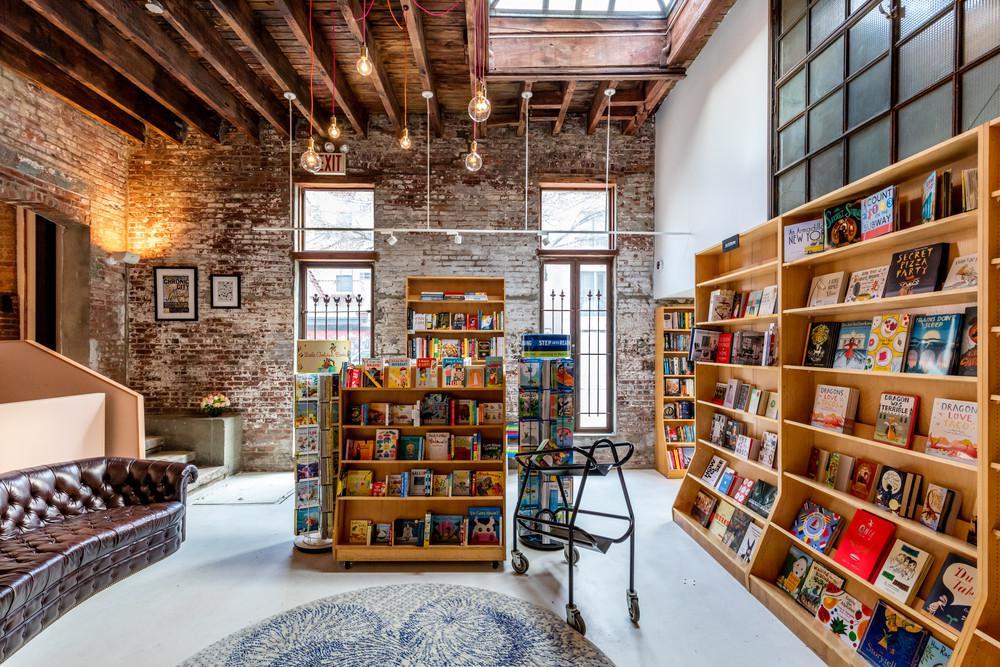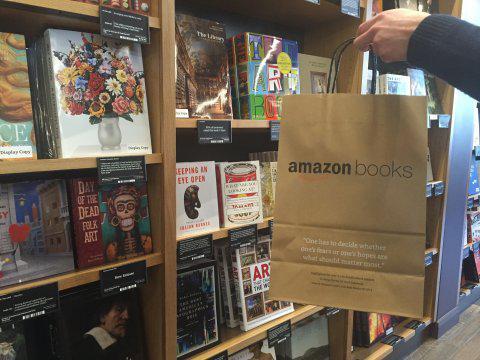The first image is the image on the left, the second image is the image on the right. Assess this claim about the two images: "No one is visible in the bookstore in the left.". Correct or not? Answer yes or no. Yes. The first image is the image on the left, the second image is the image on the right. Analyze the images presented: Is the assertion "Suspended non-tube-shaped lights are visible in at least one bookstore image." valid? Answer yes or no. Yes. 